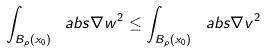Convert formula to latex. <formula><loc_0><loc_0><loc_500><loc_500>\int _ { B _ { \rho } ( x _ { 0 } ) } \ a b s { \nabla w } ^ { 2 } \leq \int _ { B _ { \rho } ( x _ { 0 } ) } \ a b s { \nabla v } ^ { 2 }</formula> 